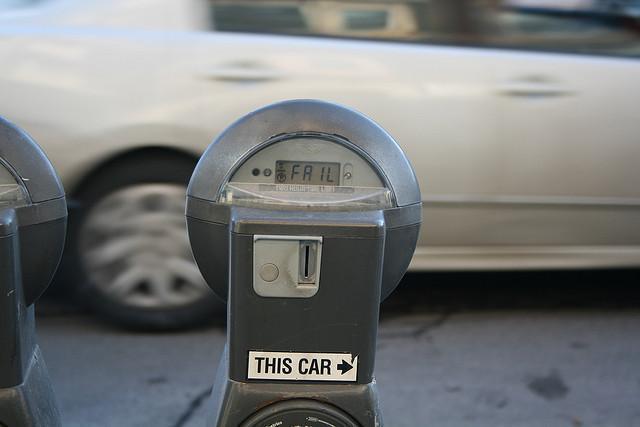Which direction is this meter pointing towards?
Choose the correct response, then elucidate: 'Answer: answer
Rationale: rationale.'
Options: Left, down, right, up. Answer: right.
Rationale: A meter has an arrow on it that points to the right. 